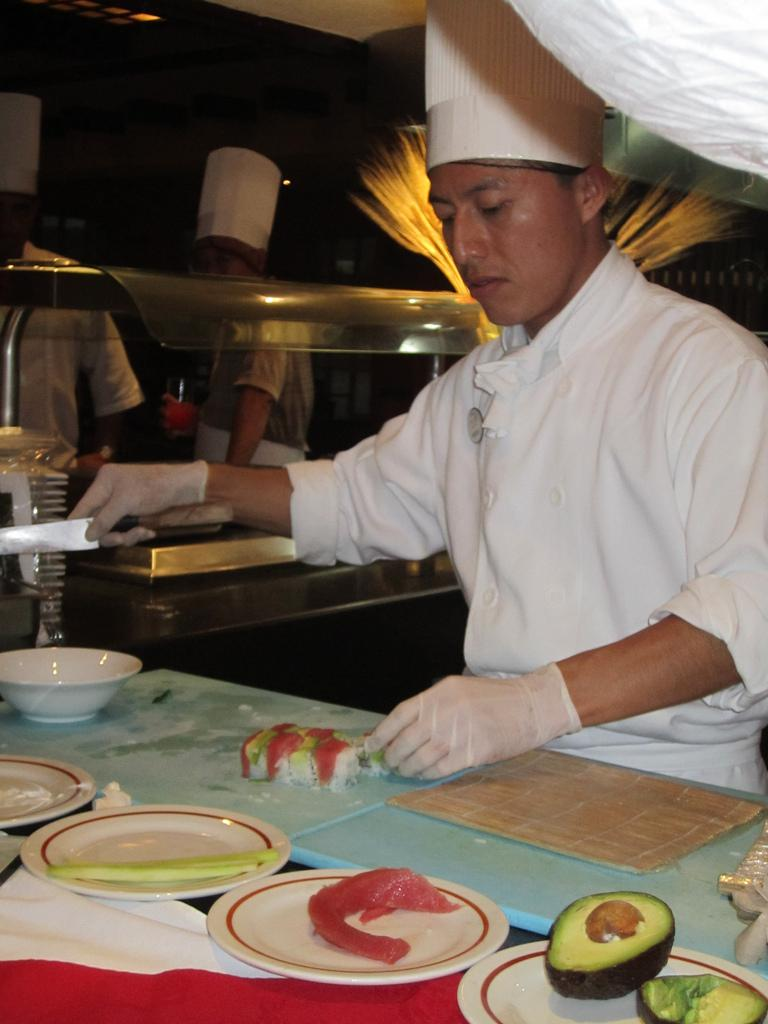Question: who is wearing gloves?
Choices:
A. The waiter.
B. The customer.
C. The janitor.
D. The chef.
Answer with the letter. Answer: D Question: what vegetable is cut in half on a plate?
Choices:
A. Avocado.
B. Pepper.
C. Carrot.
D. Celery.
Answer with the letter. Answer: A Question: why is he slicing the sushi?
Choices:
A. To eat.
B. To sell.
C. To make sushi rolls to serve.
D. To display.
Answer with the letter. Answer: C Question: how many plates are in front of him?
Choices:
A. Two.
B. Four.
C. None.
D. Eight.
Answer with the letter. Answer: B Question: where is this taking place?
Choices:
A. Italian restaurant.
B. French restaurant.
C. Indian restaurant.
D. Sushi restaurant.
Answer with the letter. Answer: D Question: what does the chef wear?
Choices:
A. Street clothes and an apron.
B. A shirt with the restaurant logo.
C. A beret.
D. White coat, hat and white gloves.
Answer with the letter. Answer: D Question: how many chefs are in the background?
Choices:
A. Four.
B. Three.
C. Two.
D. One.
Answer with the letter. Answer: C Question: how many men are there?
Choices:
A. Seven.
B. Three.
C. Four.
D. Two.
Answer with the letter. Answer: B Question: where is bowl sitting?
Choices:
A. Sink.
B. Cabinet.
C. Table.
D. On cutting surface.
Answer with the letter. Answer: D Question: where are lights?
Choices:
A. On the patio.
B. In the ceiling.
C. Along the sidewalk.
D. Above the front door.
Answer with the letter. Answer: B Question: who is using knife?
Choices:
A. The mother.
B. Chef.
C. The killer.
D. The father.
Answer with the letter. Answer: B Question: what is the chef wearing on his hands?
Choices:
A. Oven mitts.
B. Bandaids.
C. Plastic gloves.
D. Winter gloves.
Answer with the letter. Answer: C Question: who is wearing white gloves?
Choices:
A. The man.
B. The woman.
C. No one.
D. The child.
Answer with the letter. Answer: C Question: what direction is the man looking?
Choices:
A. He is looking up.
B. To the left.
C. He is looking down.
D. To the right.
Answer with the letter. Answer: C Question: what direction are the cook's eyes focusing?
Choices:
A. Upward.
B. To the left.
C. To the right.
D. Downward.
Answer with the letter. Answer: D Question: who is the chef?
Choices:
A. A black man.
B. An Asian man.
C. A white man.
D. A native american man.
Answer with the letter. Answer: B 